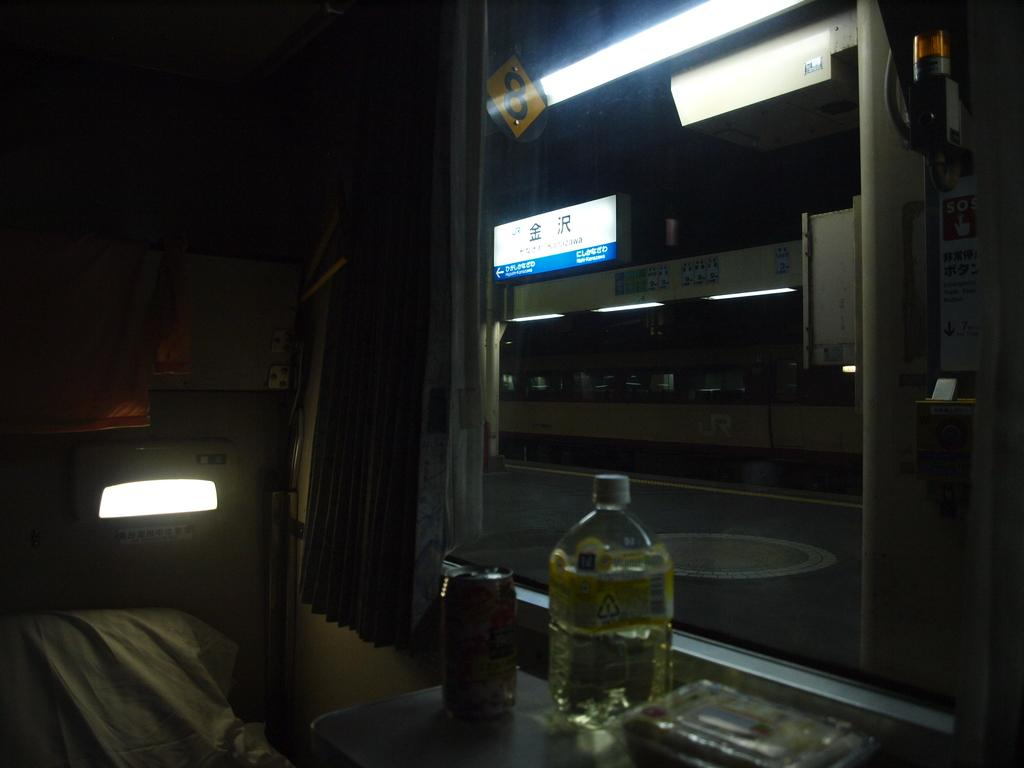What type of container is visible in the image? There is a bottle in the image. What other container can be seen in the image? There is a tin in the image. What source of illumination is present in the image? There is a light in the image. What type of display device is in the image? There is a screen in the image. Where is the beetle crawling on the screen in the image? There is no beetle present in the image. What type of furniture is shown next to the screen in the image? There is no furniture visible in the image. 